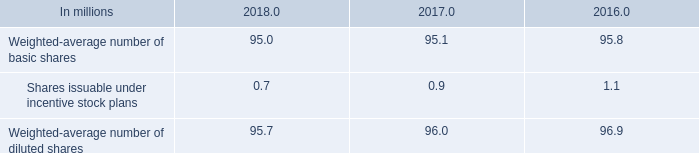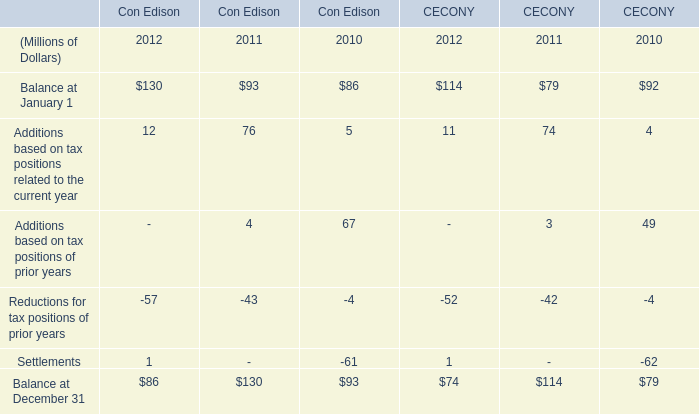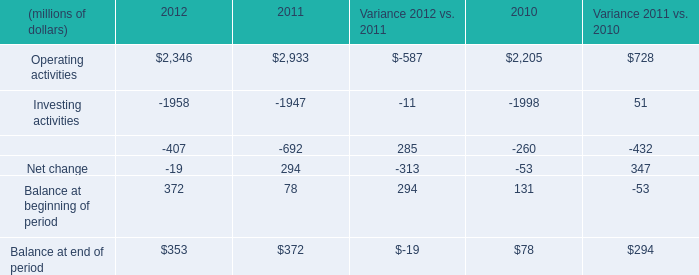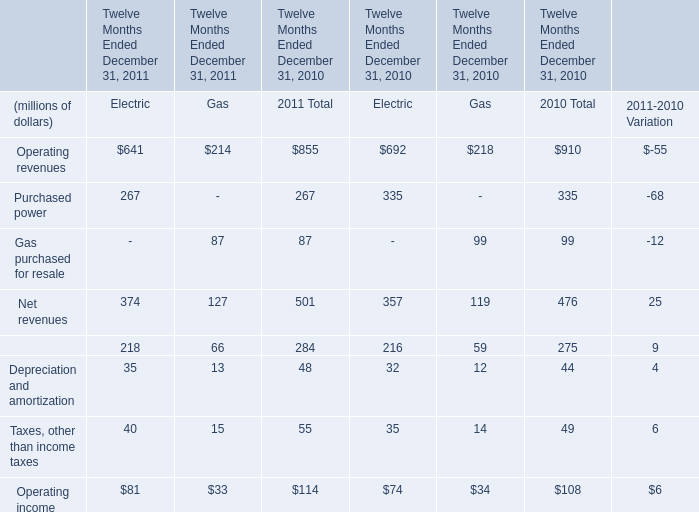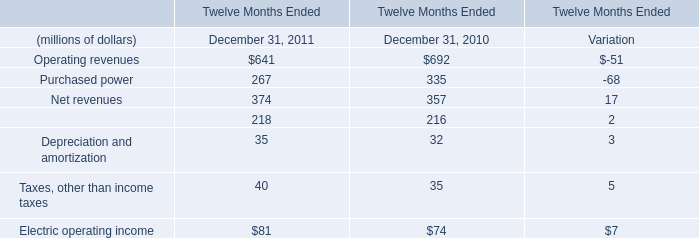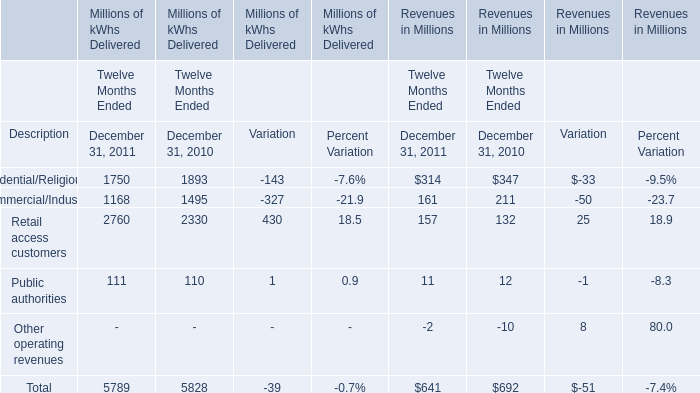What's the growth rate of Electric operating income in 2011? 
Computations: ((81 - 74) / 74)
Answer: 0.09459. 